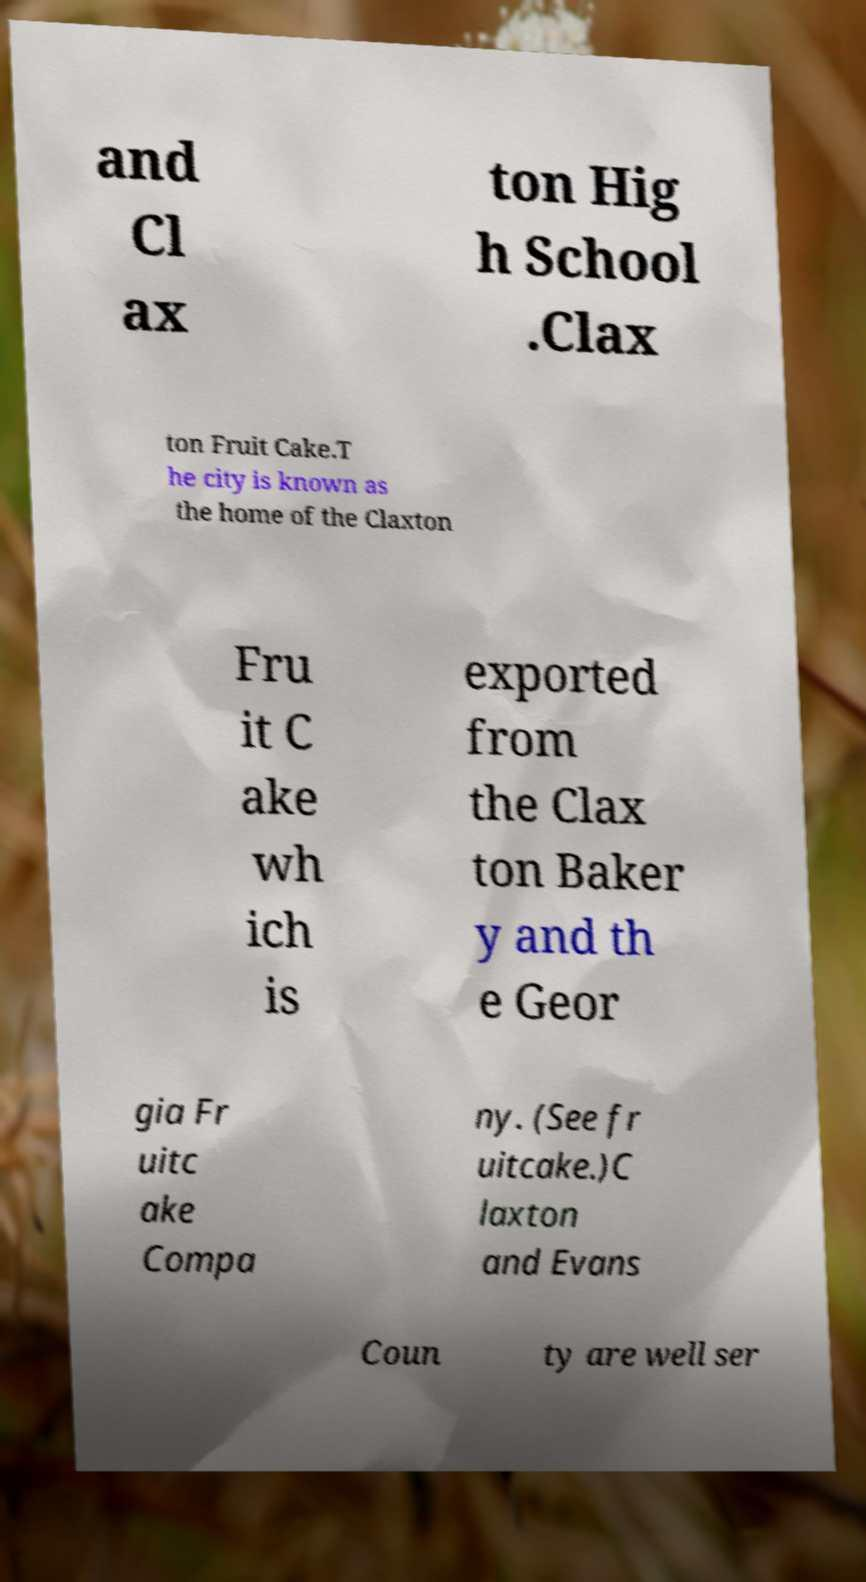Can you read and provide the text displayed in the image?This photo seems to have some interesting text. Can you extract and type it out for me? and Cl ax ton Hig h School .Clax ton Fruit Cake.T he city is known as the home of the Claxton Fru it C ake wh ich is exported from the Clax ton Baker y and th e Geor gia Fr uitc ake Compa ny. (See fr uitcake.)C laxton and Evans Coun ty are well ser 